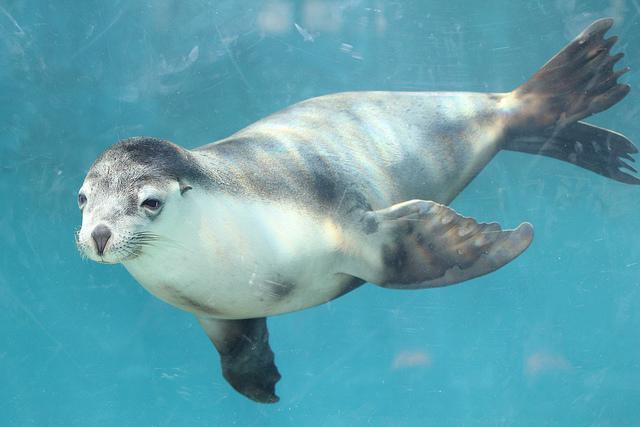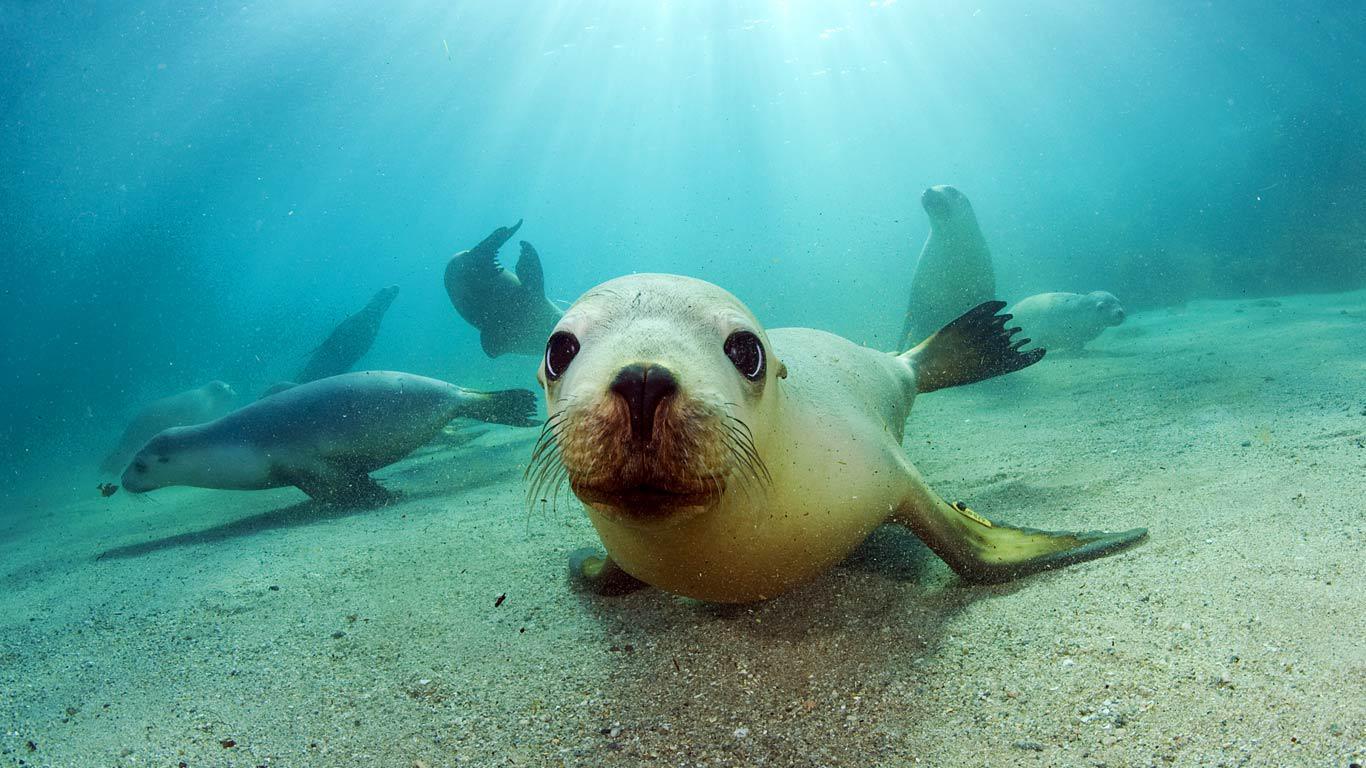The first image is the image on the left, the second image is the image on the right. For the images displayed, is the sentence "An image shows a camera-facing seal with at least four other seals underwater in the background." factually correct? Answer yes or no. Yes. 